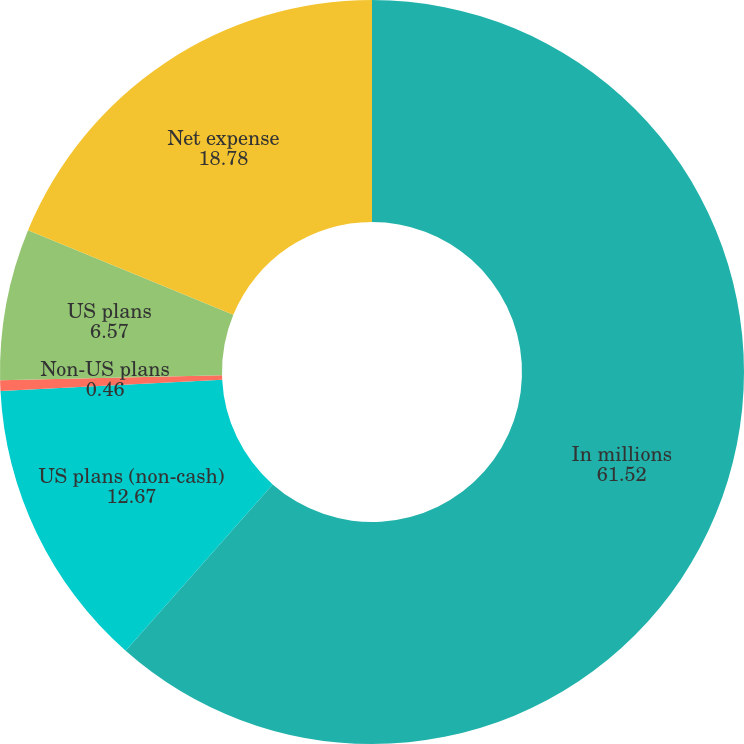Convert chart. <chart><loc_0><loc_0><loc_500><loc_500><pie_chart><fcel>In millions<fcel>US plans (non-cash)<fcel>Non-US plans<fcel>US plans<fcel>Net expense<nl><fcel>61.52%<fcel>12.67%<fcel>0.46%<fcel>6.57%<fcel>18.78%<nl></chart> 